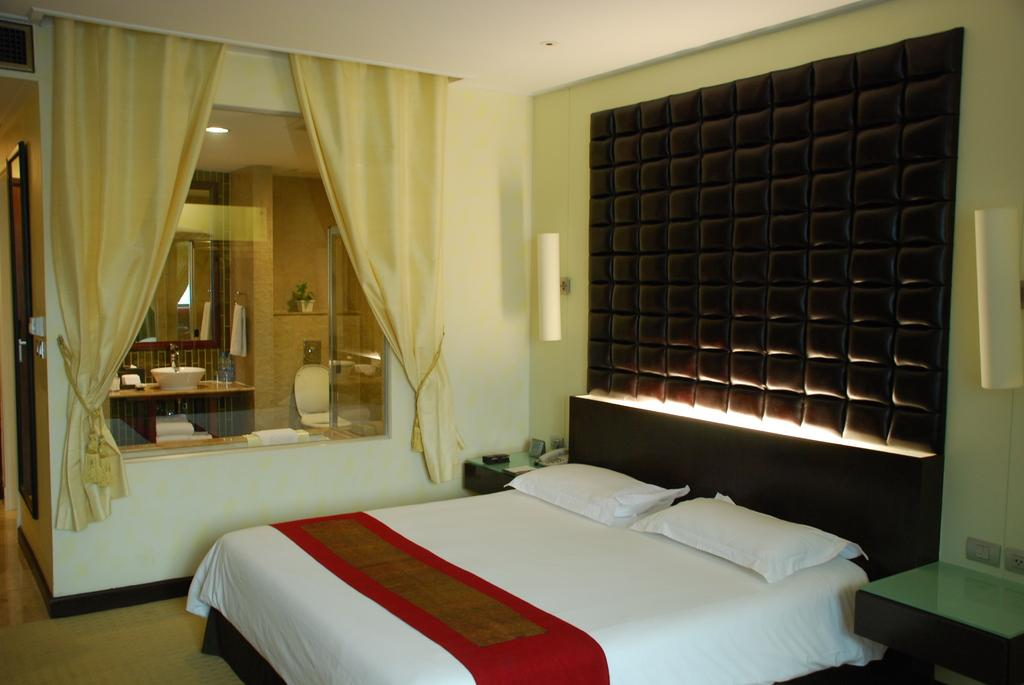What type of furniture is present in the room? There is a bed and tables in the room. What can be used for personal grooming or checking appearance in the room? There is a mirror on the wall. What might be used to cover or provide privacy for a window in the room? There is a curtain in the room. What type of cub can be seen playing with chalk in the room? There is no cub or chalk present in the room; the image only features a bed, tables, a mirror, and a curtain. 